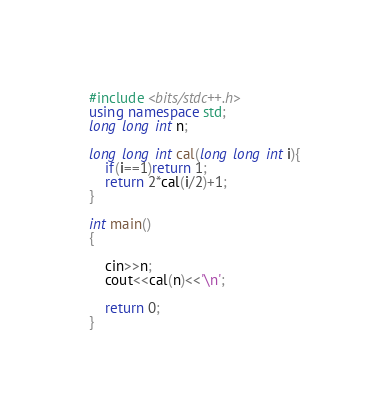<code> <loc_0><loc_0><loc_500><loc_500><_C++_>
#include <bits/stdc++.h>
using namespace std;
long long int n;

long long int cal(long long int i){
    if(i==1)return 1;
    return 2*cal(i/2)+1;
}

int main()
{
    
    cin>>n;
    cout<<cal(n)<<'\n';

    return 0;
}
</code> 